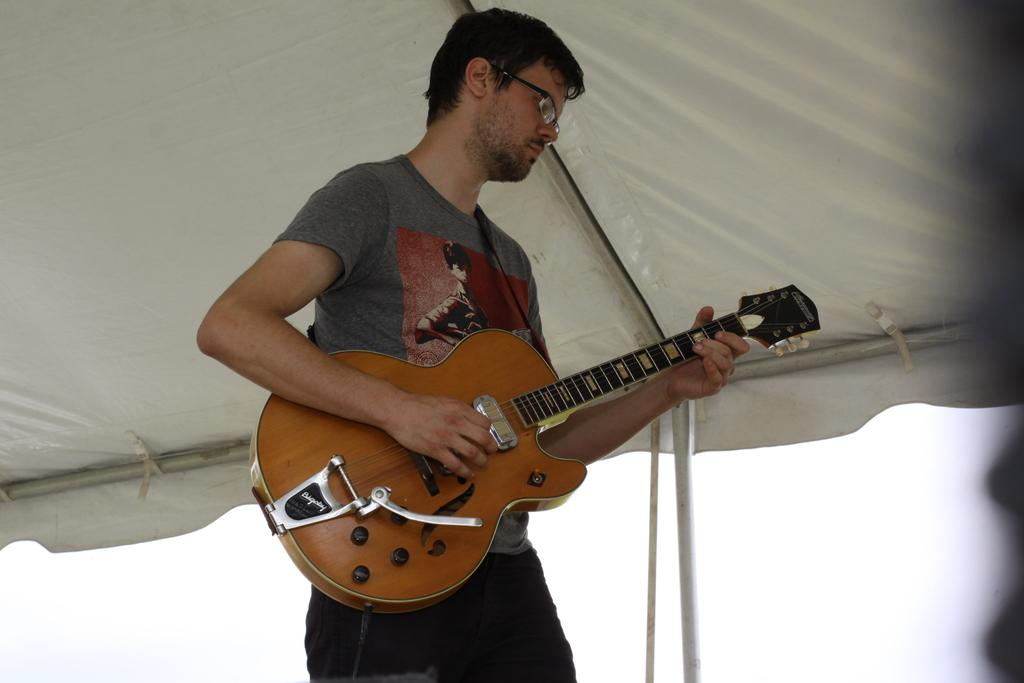What is the man in the image doing? The man is playing a guitar. What is the man wearing in the image? The man is wearing a grey t-shirt. What can be seen above the man in the image? There is a tent above the man. What accessory is the man wearing in the image? The man is wearing spectacles. What plot of land does the man own in the image? There is no information about the man owning land or any plot in the image. 